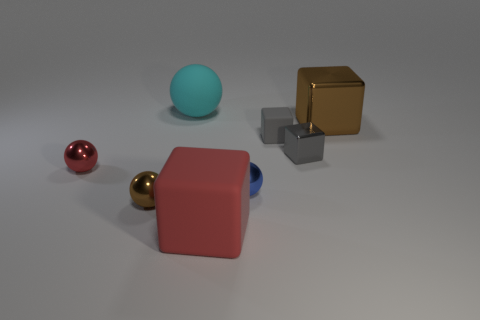Subtract all tiny red metal balls. How many balls are left? 3 Subtract all blue balls. How many balls are left? 3 Add 1 red rubber things. How many objects exist? 9 Subtract 1 balls. How many balls are left? 3 Subtract all cyan cylinders. How many gray cubes are left? 2 Add 8 big cyan cylinders. How many big cyan cylinders exist? 8 Subtract 0 green balls. How many objects are left? 8 Subtract all cyan spheres. Subtract all cyan cylinders. How many spheres are left? 3 Subtract all small blue blocks. Subtract all cyan rubber things. How many objects are left? 7 Add 2 tiny gray metallic blocks. How many tiny gray metallic blocks are left? 3 